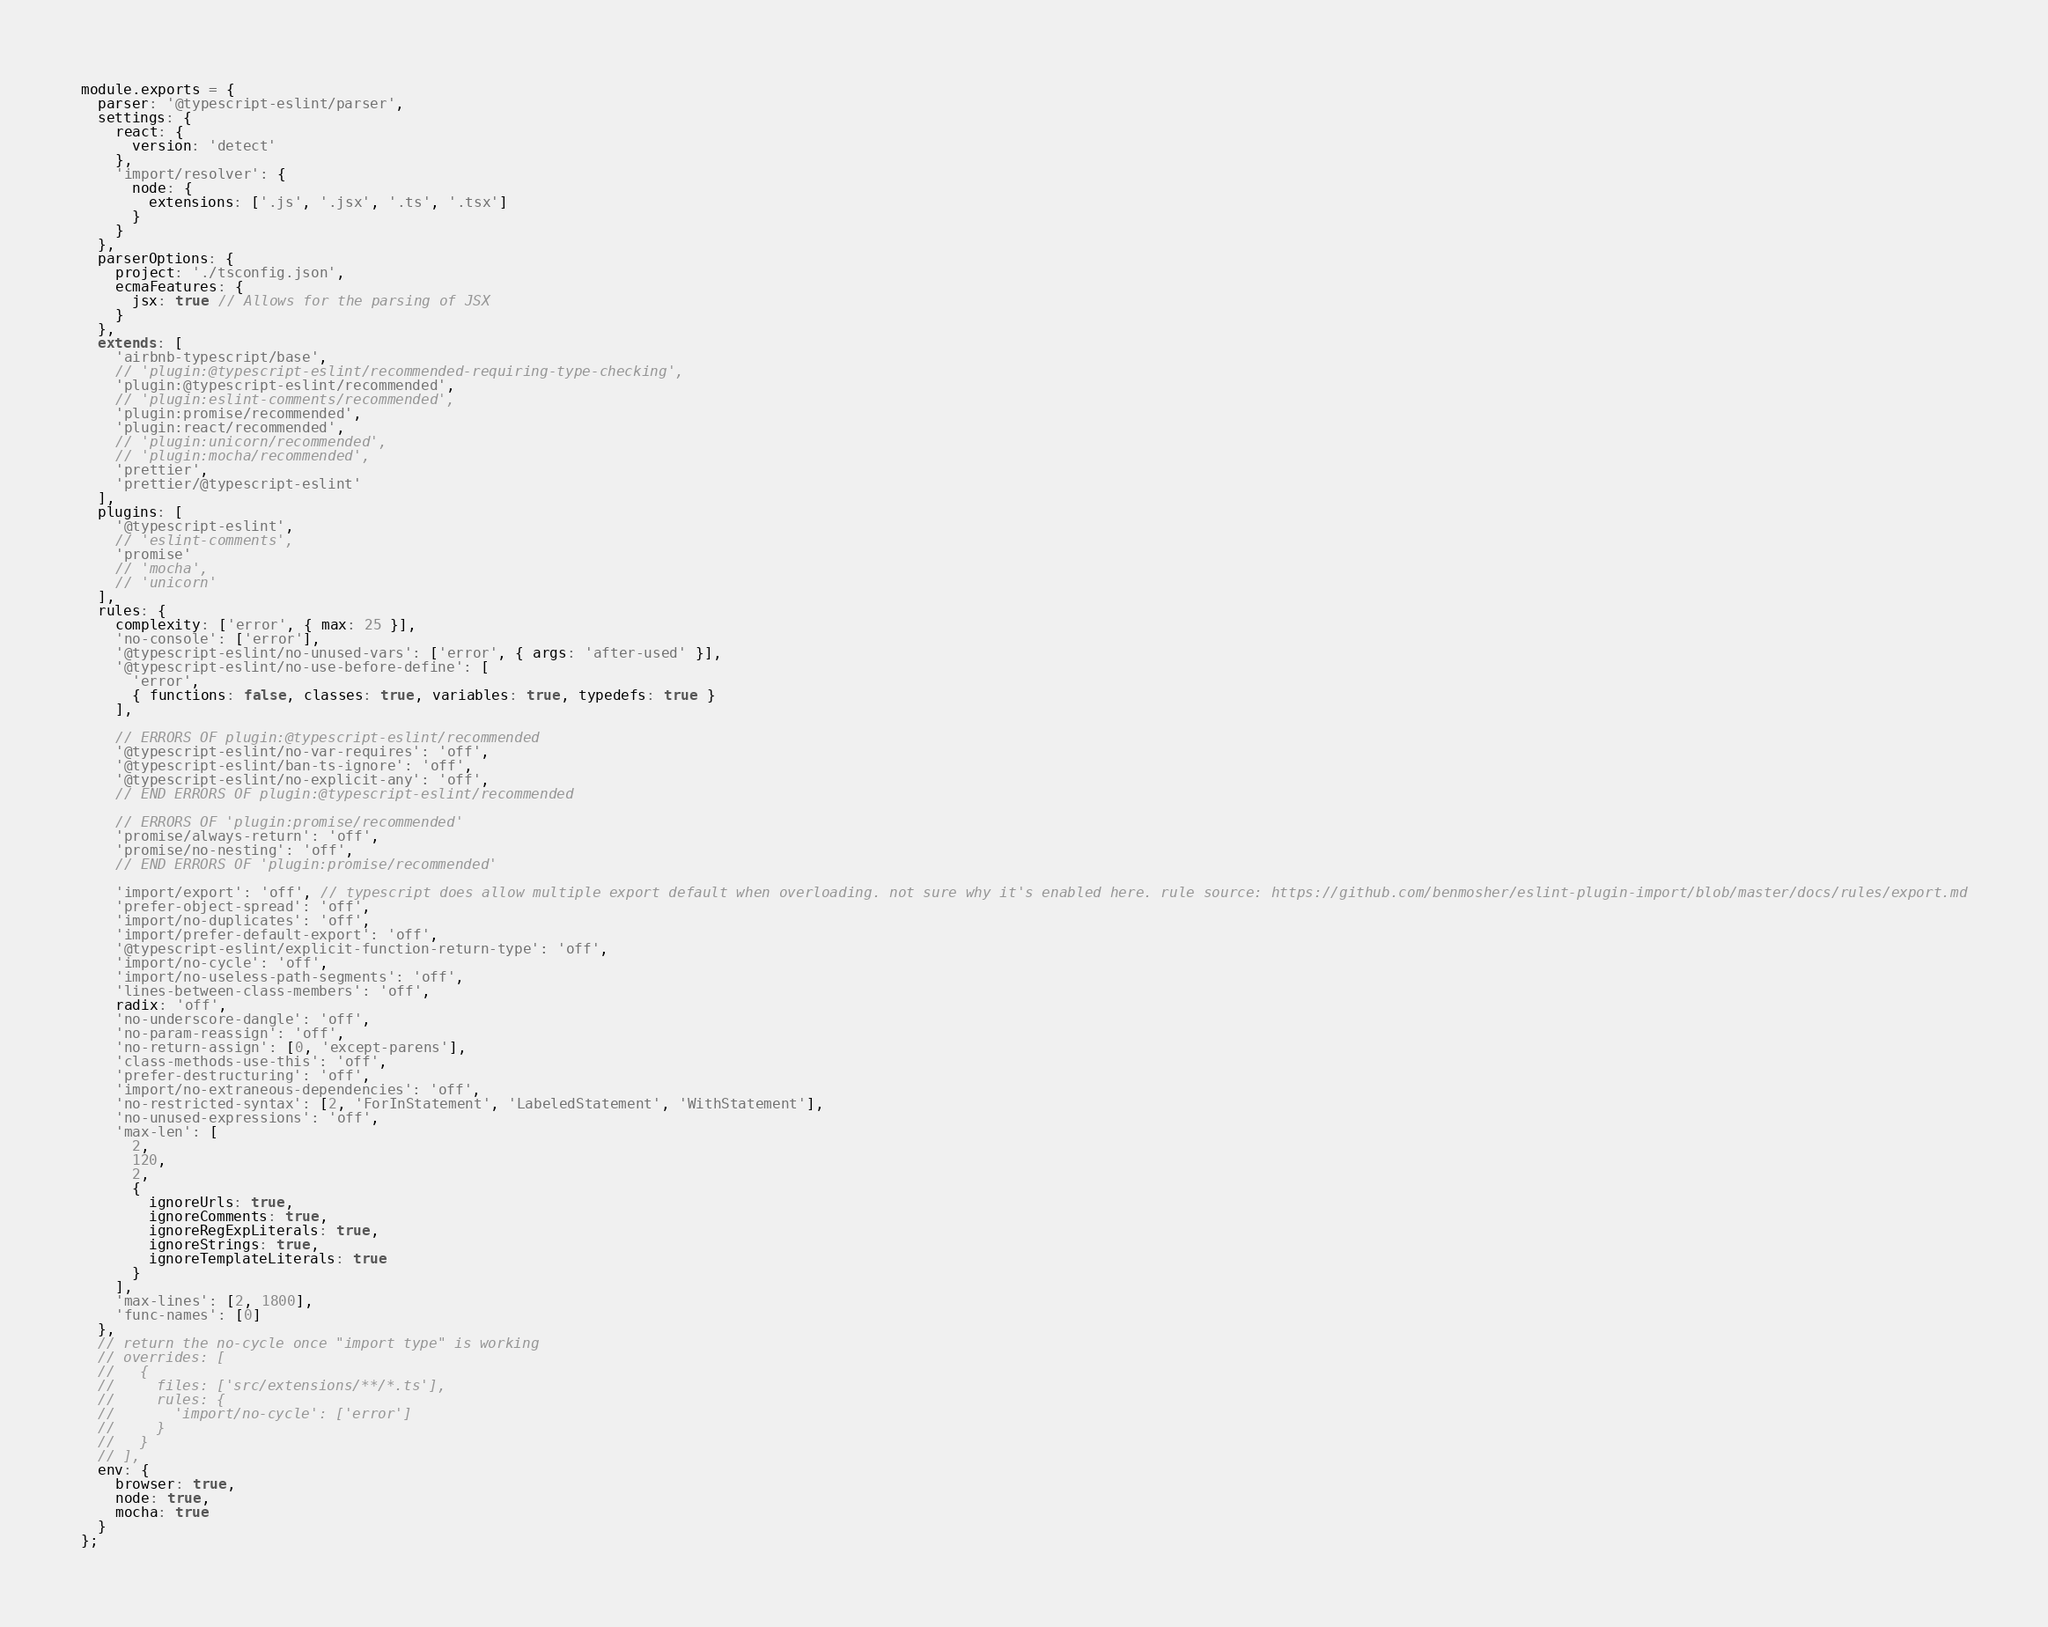<code> <loc_0><loc_0><loc_500><loc_500><_JavaScript_>module.exports = {
  parser: '@typescript-eslint/parser',
  settings: {
    react: {
      version: 'detect'
    },
    'import/resolver': {
      node: {
        extensions: ['.js', '.jsx', '.ts', '.tsx']
      }
    }
  },
  parserOptions: {
    project: './tsconfig.json',
    ecmaFeatures: {
      jsx: true // Allows for the parsing of JSX
    }
  },
  extends: [
    'airbnb-typescript/base',
    // 'plugin:@typescript-eslint/recommended-requiring-type-checking',
    'plugin:@typescript-eslint/recommended',
    // 'plugin:eslint-comments/recommended',
    'plugin:promise/recommended',
    'plugin:react/recommended',
    // 'plugin:unicorn/recommended',
    // 'plugin:mocha/recommended',
    'prettier',
    'prettier/@typescript-eslint'
  ],
  plugins: [
    '@typescript-eslint',
    // 'eslint-comments',
    'promise'
    // 'mocha',
    // 'unicorn'
  ],
  rules: {
    complexity: ['error', { max: 25 }],
    'no-console': ['error'],
    '@typescript-eslint/no-unused-vars': ['error', { args: 'after-used' }],
    '@typescript-eslint/no-use-before-define': [
      'error',
      { functions: false, classes: true, variables: true, typedefs: true }
    ],

    // ERRORS OF plugin:@typescript-eslint/recommended
    '@typescript-eslint/no-var-requires': 'off',
    '@typescript-eslint/ban-ts-ignore': 'off',
    '@typescript-eslint/no-explicit-any': 'off',
    // END ERRORS OF plugin:@typescript-eslint/recommended

    // ERRORS OF 'plugin:promise/recommended'
    'promise/always-return': 'off',
    'promise/no-nesting': 'off',
    // END ERRORS OF 'plugin:promise/recommended'

    'import/export': 'off', // typescript does allow multiple export default when overloading. not sure why it's enabled here. rule source: https://github.com/benmosher/eslint-plugin-import/blob/master/docs/rules/export.md
    'prefer-object-spread': 'off',
    'import/no-duplicates': 'off',
    'import/prefer-default-export': 'off',
    '@typescript-eslint/explicit-function-return-type': 'off',
    'import/no-cycle': 'off',
    'import/no-useless-path-segments': 'off',
    'lines-between-class-members': 'off',
    radix: 'off',
    'no-underscore-dangle': 'off',
    'no-param-reassign': 'off',
    'no-return-assign': [0, 'except-parens'],
    'class-methods-use-this': 'off',
    'prefer-destructuring': 'off',
    'import/no-extraneous-dependencies': 'off',
    'no-restricted-syntax': [2, 'ForInStatement', 'LabeledStatement', 'WithStatement'],
    'no-unused-expressions': 'off',
    'max-len': [
      2,
      120,
      2,
      {
        ignoreUrls: true,
        ignoreComments: true,
        ignoreRegExpLiterals: true,
        ignoreStrings: true,
        ignoreTemplateLiterals: true
      }
    ],
    'max-lines': [2, 1800],
    'func-names': [0]
  },
  // return the no-cycle once "import type" is working
  // overrides: [
  //   {
  //     files: ['src/extensions/**/*.ts'],
  //     rules: {
  //       'import/no-cycle': ['error']
  //     }
  //   }
  // ],
  env: {
    browser: true,
    node: true,
    mocha: true
  }
};
</code> 